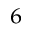Convert formula to latex. <formula><loc_0><loc_0><loc_500><loc_500>^ { 6 }</formula> 